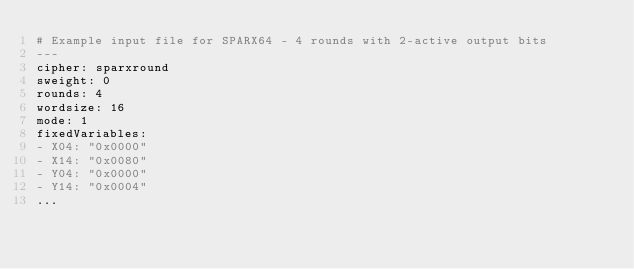Convert code to text. <code><loc_0><loc_0><loc_500><loc_500><_YAML_># Example input file for SPARX64 - 4 rounds with 2-active output bits
---
cipher: sparxround
sweight: 0
rounds: 4
wordsize: 16
mode: 1
fixedVariables:
- X04: "0x0000"
- X14: "0x0080"
- Y04: "0x0000"
- Y14: "0x0004"
...

</code> 